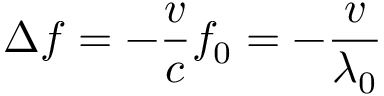Convert formula to latex. <formula><loc_0><loc_0><loc_500><loc_500>f = - \frac { v } { c } f _ { 0 } = - \frac { v } { \lambda _ { 0 } }</formula> 